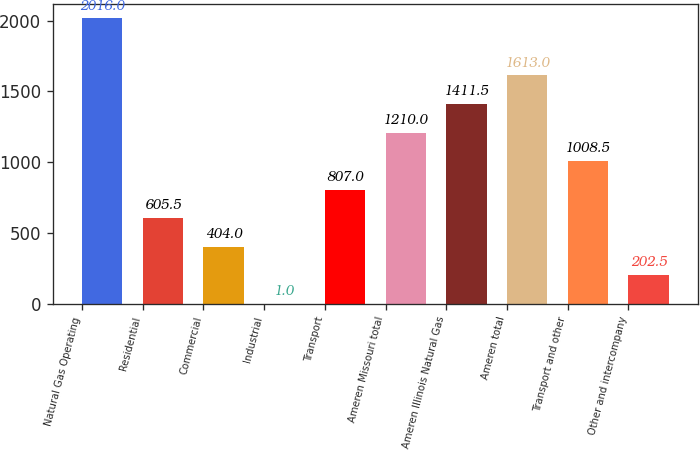Convert chart to OTSL. <chart><loc_0><loc_0><loc_500><loc_500><bar_chart><fcel>Natural Gas Operating<fcel>Residential<fcel>Commercial<fcel>Industrial<fcel>Transport<fcel>Ameren Missouri total<fcel>Ameren Illinois Natural Gas<fcel>Ameren total<fcel>Transport and other<fcel>Other and intercompany<nl><fcel>2016<fcel>605.5<fcel>404<fcel>1<fcel>807<fcel>1210<fcel>1411.5<fcel>1613<fcel>1008.5<fcel>202.5<nl></chart> 